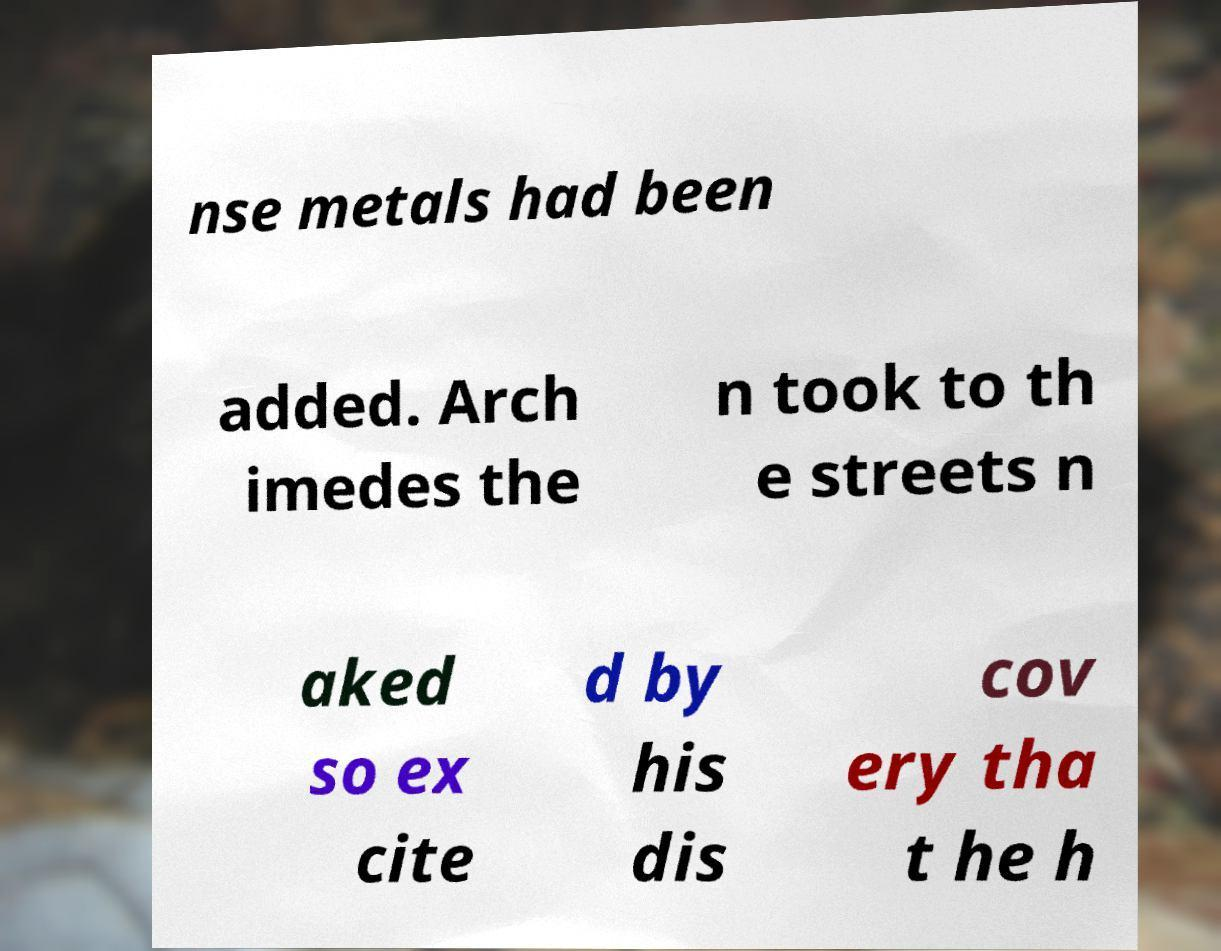There's text embedded in this image that I need extracted. Can you transcribe it verbatim? nse metals had been added. Arch imedes the n took to th e streets n aked so ex cite d by his dis cov ery tha t he h 